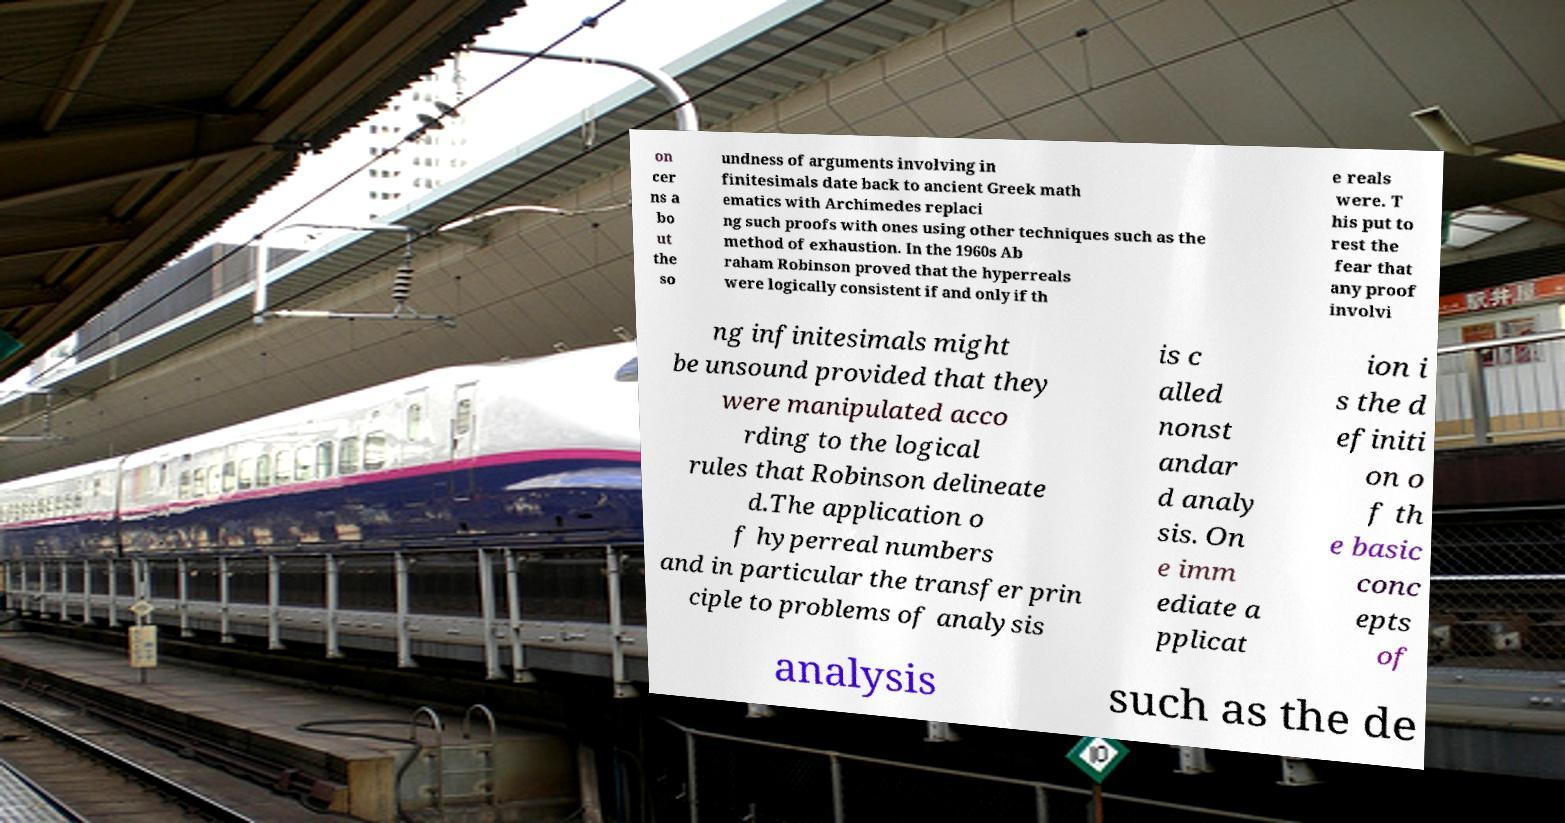Can you read and provide the text displayed in the image?This photo seems to have some interesting text. Can you extract and type it out for me? on cer ns a bo ut the so undness of arguments involving in finitesimals date back to ancient Greek math ematics with Archimedes replaci ng such proofs with ones using other techniques such as the method of exhaustion. In the 1960s Ab raham Robinson proved that the hyperreals were logically consistent if and only if th e reals were. T his put to rest the fear that any proof involvi ng infinitesimals might be unsound provided that they were manipulated acco rding to the logical rules that Robinson delineate d.The application o f hyperreal numbers and in particular the transfer prin ciple to problems of analysis is c alled nonst andar d analy sis. On e imm ediate a pplicat ion i s the d efiniti on o f th e basic conc epts of analysis such as the de 